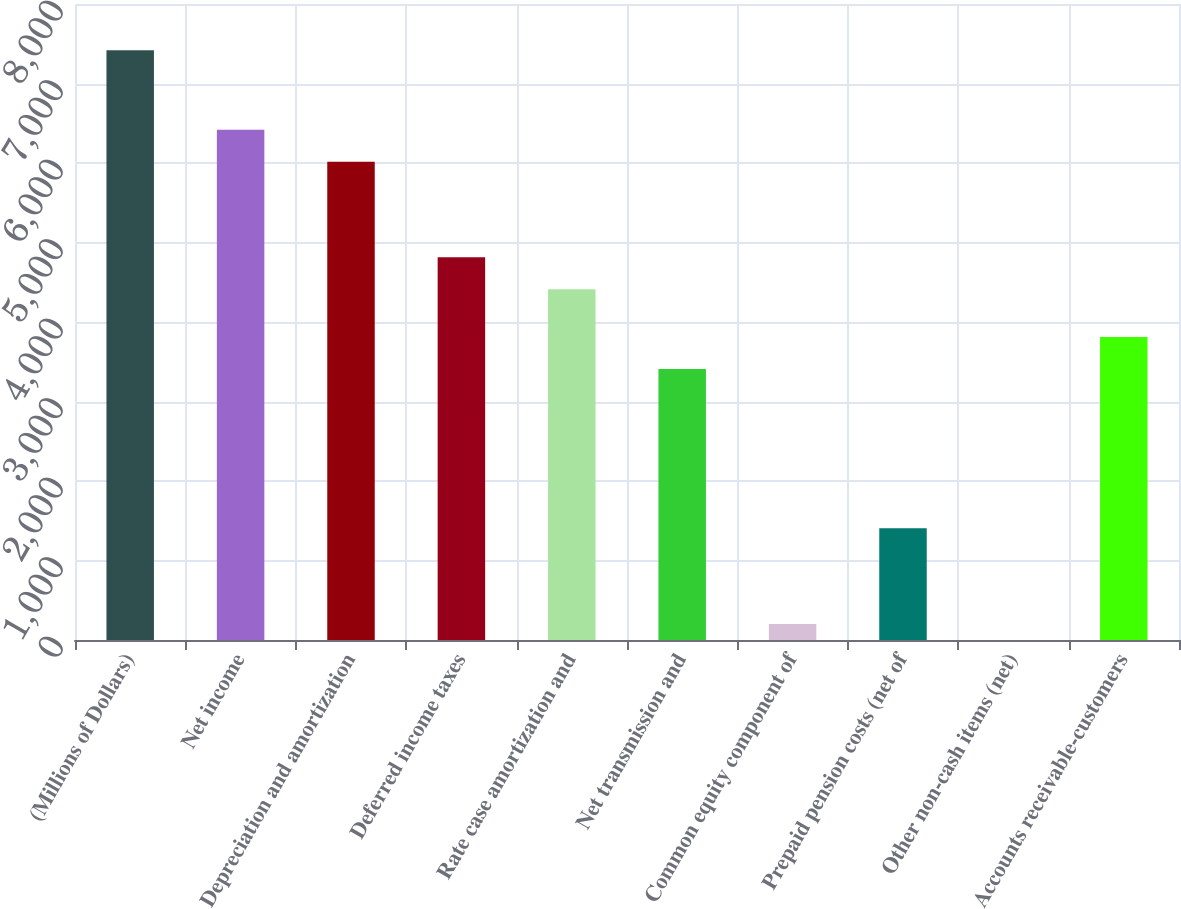Convert chart. <chart><loc_0><loc_0><loc_500><loc_500><bar_chart><fcel>(Millions of Dollars)<fcel>Net income<fcel>Depreciation and amortization<fcel>Deferred income taxes<fcel>Rate case amortization and<fcel>Net transmission and<fcel>Common equity component of<fcel>Prepaid pension costs (net of<fcel>Other non-cash items (net)<fcel>Accounts receivable-customers<nl><fcel>7419.5<fcel>6417<fcel>6016<fcel>4813<fcel>4412<fcel>3409.5<fcel>201.5<fcel>1404.5<fcel>1<fcel>3810.5<nl></chart> 